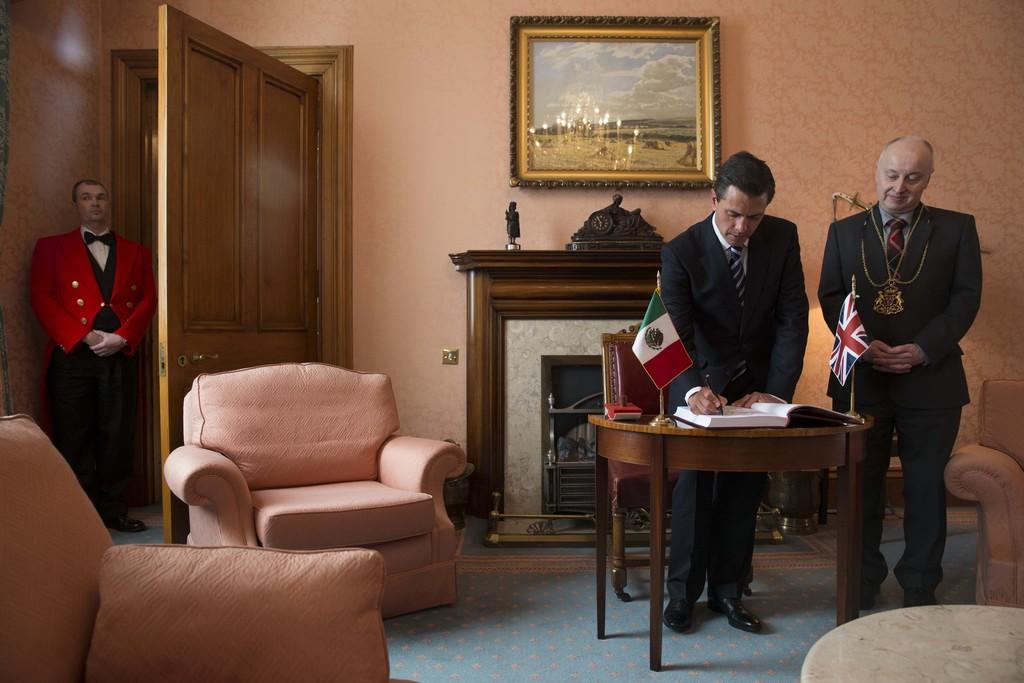Could you give a brief overview of what you see in this image? This image consists of three men standing in the room. At right side the man is standing wearing a suit. In the center man standing is writing on the book which is on the table. There are two flags on the table. Sofa set in the room. At the left side the man wearing red colour suit is standing at the door. In the background there is a frame hang on the wall. 